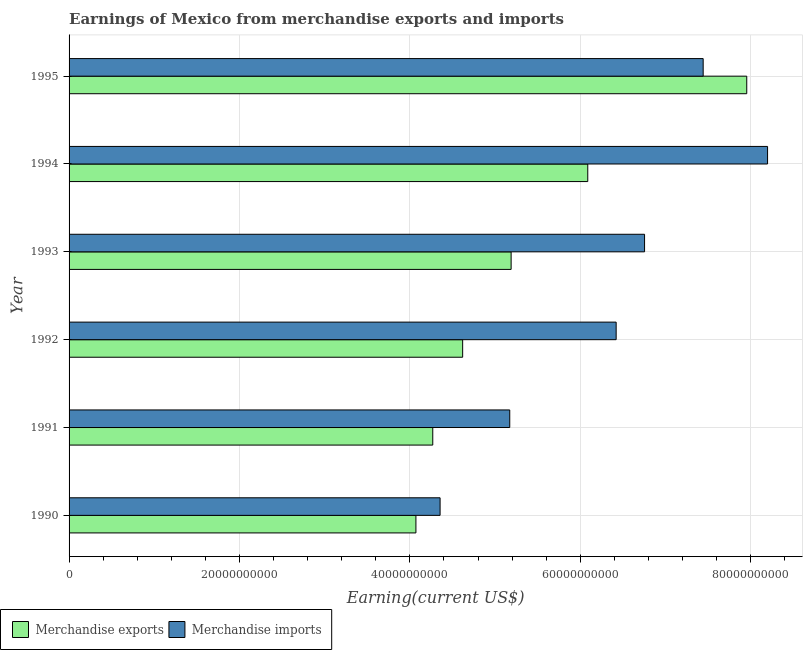How many bars are there on the 5th tick from the bottom?
Offer a very short reply. 2. What is the label of the 2nd group of bars from the top?
Ensure brevity in your answer.  1994. What is the earnings from merchandise exports in 1995?
Your answer should be very brief. 7.95e+1. Across all years, what is the maximum earnings from merchandise exports?
Your response must be concise. 7.95e+1. Across all years, what is the minimum earnings from merchandise imports?
Your answer should be compact. 4.35e+1. What is the total earnings from merchandise imports in the graph?
Keep it short and to the point. 3.83e+11. What is the difference between the earnings from merchandise exports in 1992 and that in 1994?
Make the answer very short. -1.47e+1. What is the difference between the earnings from merchandise imports in 1992 and the earnings from merchandise exports in 1995?
Ensure brevity in your answer.  -1.53e+1. What is the average earnings from merchandise imports per year?
Offer a very short reply. 6.39e+1. In the year 1992, what is the difference between the earnings from merchandise exports and earnings from merchandise imports?
Provide a short and direct response. -1.80e+1. What is the ratio of the earnings from merchandise exports in 1993 to that in 1995?
Give a very brief answer. 0.65. Is the difference between the earnings from merchandise exports in 1990 and 1991 greater than the difference between the earnings from merchandise imports in 1990 and 1991?
Your answer should be compact. Yes. What is the difference between the highest and the second highest earnings from merchandise exports?
Keep it short and to the point. 1.87e+1. What is the difference between the highest and the lowest earnings from merchandise exports?
Make the answer very short. 3.88e+1. Is the sum of the earnings from merchandise imports in 1991 and 1995 greater than the maximum earnings from merchandise exports across all years?
Offer a very short reply. Yes. What does the 2nd bar from the top in 1995 represents?
Offer a terse response. Merchandise exports. What does the 2nd bar from the bottom in 1991 represents?
Give a very brief answer. Merchandise imports. How many years are there in the graph?
Your response must be concise. 6. What is the difference between two consecutive major ticks on the X-axis?
Keep it short and to the point. 2.00e+1. Are the values on the major ticks of X-axis written in scientific E-notation?
Provide a succinct answer. No. How many legend labels are there?
Provide a short and direct response. 2. How are the legend labels stacked?
Provide a succinct answer. Horizontal. What is the title of the graph?
Ensure brevity in your answer.  Earnings of Mexico from merchandise exports and imports. What is the label or title of the X-axis?
Your answer should be compact. Earning(current US$). What is the label or title of the Y-axis?
Your answer should be compact. Year. What is the Earning(current US$) in Merchandise exports in 1990?
Your response must be concise. 4.07e+1. What is the Earning(current US$) in Merchandise imports in 1990?
Offer a terse response. 4.35e+1. What is the Earning(current US$) of Merchandise exports in 1991?
Make the answer very short. 4.27e+1. What is the Earning(current US$) of Merchandise imports in 1991?
Provide a succinct answer. 5.17e+1. What is the Earning(current US$) in Merchandise exports in 1992?
Your answer should be compact. 4.62e+1. What is the Earning(current US$) of Merchandise imports in 1992?
Your answer should be compact. 6.42e+1. What is the Earning(current US$) in Merchandise exports in 1993?
Offer a very short reply. 5.19e+1. What is the Earning(current US$) of Merchandise imports in 1993?
Your answer should be very brief. 6.75e+1. What is the Earning(current US$) of Merchandise exports in 1994?
Give a very brief answer. 6.09e+1. What is the Earning(current US$) in Merchandise imports in 1994?
Keep it short and to the point. 8.20e+1. What is the Earning(current US$) in Merchandise exports in 1995?
Your answer should be compact. 7.95e+1. What is the Earning(current US$) of Merchandise imports in 1995?
Keep it short and to the point. 7.44e+1. Across all years, what is the maximum Earning(current US$) in Merchandise exports?
Make the answer very short. 7.95e+1. Across all years, what is the maximum Earning(current US$) in Merchandise imports?
Your answer should be compact. 8.20e+1. Across all years, what is the minimum Earning(current US$) of Merchandise exports?
Your answer should be compact. 4.07e+1. Across all years, what is the minimum Earning(current US$) in Merchandise imports?
Give a very brief answer. 4.35e+1. What is the total Earning(current US$) in Merchandise exports in the graph?
Your answer should be very brief. 3.22e+11. What is the total Earning(current US$) in Merchandise imports in the graph?
Provide a succinct answer. 3.83e+11. What is the difference between the Earning(current US$) in Merchandise exports in 1990 and that in 1991?
Ensure brevity in your answer.  -1.98e+09. What is the difference between the Earning(current US$) in Merchandise imports in 1990 and that in 1991?
Offer a very short reply. -8.18e+09. What is the difference between the Earning(current US$) of Merchandise exports in 1990 and that in 1992?
Your answer should be compact. -5.48e+09. What is the difference between the Earning(current US$) of Merchandise imports in 1990 and that in 1992?
Offer a terse response. -2.07e+1. What is the difference between the Earning(current US$) in Merchandise exports in 1990 and that in 1993?
Offer a terse response. -1.12e+1. What is the difference between the Earning(current US$) of Merchandise imports in 1990 and that in 1993?
Offer a terse response. -2.40e+1. What is the difference between the Earning(current US$) of Merchandise exports in 1990 and that in 1994?
Give a very brief answer. -2.02e+1. What is the difference between the Earning(current US$) of Merchandise imports in 1990 and that in 1994?
Your response must be concise. -3.84e+1. What is the difference between the Earning(current US$) in Merchandise exports in 1990 and that in 1995?
Offer a very short reply. -3.88e+1. What is the difference between the Earning(current US$) of Merchandise imports in 1990 and that in 1995?
Offer a very short reply. -3.09e+1. What is the difference between the Earning(current US$) in Merchandise exports in 1991 and that in 1992?
Offer a terse response. -3.51e+09. What is the difference between the Earning(current US$) in Merchandise imports in 1991 and that in 1992?
Offer a very short reply. -1.25e+1. What is the difference between the Earning(current US$) in Merchandise exports in 1991 and that in 1993?
Provide a succinct answer. -9.20e+09. What is the difference between the Earning(current US$) in Merchandise imports in 1991 and that in 1993?
Provide a succinct answer. -1.58e+1. What is the difference between the Earning(current US$) in Merchandise exports in 1991 and that in 1994?
Provide a short and direct response. -1.82e+1. What is the difference between the Earning(current US$) of Merchandise imports in 1991 and that in 1994?
Your answer should be very brief. -3.03e+1. What is the difference between the Earning(current US$) in Merchandise exports in 1991 and that in 1995?
Offer a very short reply. -3.69e+1. What is the difference between the Earning(current US$) of Merchandise imports in 1991 and that in 1995?
Make the answer very short. -2.27e+1. What is the difference between the Earning(current US$) in Merchandise exports in 1992 and that in 1993?
Make the answer very short. -5.69e+09. What is the difference between the Earning(current US$) of Merchandise imports in 1992 and that in 1993?
Offer a terse response. -3.33e+09. What is the difference between the Earning(current US$) of Merchandise exports in 1992 and that in 1994?
Your response must be concise. -1.47e+1. What is the difference between the Earning(current US$) in Merchandise imports in 1992 and that in 1994?
Provide a succinct answer. -1.78e+1. What is the difference between the Earning(current US$) of Merchandise exports in 1992 and that in 1995?
Make the answer very short. -3.33e+1. What is the difference between the Earning(current US$) in Merchandise imports in 1992 and that in 1995?
Give a very brief answer. -1.02e+1. What is the difference between the Earning(current US$) of Merchandise exports in 1993 and that in 1994?
Your answer should be compact. -9.00e+09. What is the difference between the Earning(current US$) of Merchandise imports in 1993 and that in 1994?
Offer a terse response. -1.44e+1. What is the difference between the Earning(current US$) in Merchandise exports in 1993 and that in 1995?
Keep it short and to the point. -2.77e+1. What is the difference between the Earning(current US$) in Merchandise imports in 1993 and that in 1995?
Your response must be concise. -6.88e+09. What is the difference between the Earning(current US$) of Merchandise exports in 1994 and that in 1995?
Offer a very short reply. -1.87e+1. What is the difference between the Earning(current US$) in Merchandise imports in 1994 and that in 1995?
Make the answer very short. 7.56e+09. What is the difference between the Earning(current US$) of Merchandise exports in 1990 and the Earning(current US$) of Merchandise imports in 1991?
Offer a very short reply. -1.10e+1. What is the difference between the Earning(current US$) in Merchandise exports in 1990 and the Earning(current US$) in Merchandise imports in 1992?
Offer a terse response. -2.35e+1. What is the difference between the Earning(current US$) in Merchandise exports in 1990 and the Earning(current US$) in Merchandise imports in 1993?
Offer a very short reply. -2.68e+1. What is the difference between the Earning(current US$) in Merchandise exports in 1990 and the Earning(current US$) in Merchandise imports in 1994?
Provide a short and direct response. -4.13e+1. What is the difference between the Earning(current US$) in Merchandise exports in 1990 and the Earning(current US$) in Merchandise imports in 1995?
Provide a succinct answer. -3.37e+1. What is the difference between the Earning(current US$) in Merchandise exports in 1991 and the Earning(current US$) in Merchandise imports in 1992?
Offer a terse response. -2.15e+1. What is the difference between the Earning(current US$) in Merchandise exports in 1991 and the Earning(current US$) in Merchandise imports in 1993?
Your response must be concise. -2.49e+1. What is the difference between the Earning(current US$) of Merchandise exports in 1991 and the Earning(current US$) of Merchandise imports in 1994?
Provide a short and direct response. -3.93e+1. What is the difference between the Earning(current US$) in Merchandise exports in 1991 and the Earning(current US$) in Merchandise imports in 1995?
Provide a short and direct response. -3.17e+1. What is the difference between the Earning(current US$) of Merchandise exports in 1992 and the Earning(current US$) of Merchandise imports in 1993?
Offer a very short reply. -2.14e+1. What is the difference between the Earning(current US$) of Merchandise exports in 1992 and the Earning(current US$) of Merchandise imports in 1994?
Offer a very short reply. -3.58e+1. What is the difference between the Earning(current US$) of Merchandise exports in 1992 and the Earning(current US$) of Merchandise imports in 1995?
Your answer should be compact. -2.82e+1. What is the difference between the Earning(current US$) in Merchandise exports in 1993 and the Earning(current US$) in Merchandise imports in 1994?
Offer a terse response. -3.01e+1. What is the difference between the Earning(current US$) in Merchandise exports in 1993 and the Earning(current US$) in Merchandise imports in 1995?
Your answer should be very brief. -2.25e+1. What is the difference between the Earning(current US$) of Merchandise exports in 1994 and the Earning(current US$) of Merchandise imports in 1995?
Provide a succinct answer. -1.35e+1. What is the average Earning(current US$) of Merchandise exports per year?
Offer a terse response. 5.37e+1. What is the average Earning(current US$) of Merchandise imports per year?
Provide a short and direct response. 6.39e+1. In the year 1990, what is the difference between the Earning(current US$) in Merchandise exports and Earning(current US$) in Merchandise imports?
Offer a very short reply. -2.84e+09. In the year 1991, what is the difference between the Earning(current US$) of Merchandise exports and Earning(current US$) of Merchandise imports?
Keep it short and to the point. -9.04e+09. In the year 1992, what is the difference between the Earning(current US$) in Merchandise exports and Earning(current US$) in Merchandise imports?
Your answer should be very brief. -1.80e+1. In the year 1993, what is the difference between the Earning(current US$) of Merchandise exports and Earning(current US$) of Merchandise imports?
Give a very brief answer. -1.57e+1. In the year 1994, what is the difference between the Earning(current US$) in Merchandise exports and Earning(current US$) in Merchandise imports?
Provide a short and direct response. -2.11e+1. In the year 1995, what is the difference between the Earning(current US$) of Merchandise exports and Earning(current US$) of Merchandise imports?
Ensure brevity in your answer.  5.11e+09. What is the ratio of the Earning(current US$) of Merchandise exports in 1990 to that in 1991?
Provide a succinct answer. 0.95. What is the ratio of the Earning(current US$) of Merchandise imports in 1990 to that in 1991?
Provide a succinct answer. 0.84. What is the ratio of the Earning(current US$) of Merchandise exports in 1990 to that in 1992?
Offer a terse response. 0.88. What is the ratio of the Earning(current US$) of Merchandise imports in 1990 to that in 1992?
Ensure brevity in your answer.  0.68. What is the ratio of the Earning(current US$) in Merchandise exports in 1990 to that in 1993?
Give a very brief answer. 0.78. What is the ratio of the Earning(current US$) in Merchandise imports in 1990 to that in 1993?
Keep it short and to the point. 0.64. What is the ratio of the Earning(current US$) in Merchandise exports in 1990 to that in 1994?
Ensure brevity in your answer.  0.67. What is the ratio of the Earning(current US$) of Merchandise imports in 1990 to that in 1994?
Offer a very short reply. 0.53. What is the ratio of the Earning(current US$) in Merchandise exports in 1990 to that in 1995?
Your answer should be very brief. 0.51. What is the ratio of the Earning(current US$) of Merchandise imports in 1990 to that in 1995?
Give a very brief answer. 0.59. What is the ratio of the Earning(current US$) of Merchandise exports in 1991 to that in 1992?
Provide a succinct answer. 0.92. What is the ratio of the Earning(current US$) of Merchandise imports in 1991 to that in 1992?
Your answer should be very brief. 0.81. What is the ratio of the Earning(current US$) in Merchandise exports in 1991 to that in 1993?
Provide a short and direct response. 0.82. What is the ratio of the Earning(current US$) in Merchandise imports in 1991 to that in 1993?
Keep it short and to the point. 0.77. What is the ratio of the Earning(current US$) in Merchandise exports in 1991 to that in 1994?
Your response must be concise. 0.7. What is the ratio of the Earning(current US$) of Merchandise imports in 1991 to that in 1994?
Your answer should be compact. 0.63. What is the ratio of the Earning(current US$) of Merchandise exports in 1991 to that in 1995?
Your response must be concise. 0.54. What is the ratio of the Earning(current US$) in Merchandise imports in 1991 to that in 1995?
Your answer should be compact. 0.69. What is the ratio of the Earning(current US$) in Merchandise exports in 1992 to that in 1993?
Your answer should be compact. 0.89. What is the ratio of the Earning(current US$) in Merchandise imports in 1992 to that in 1993?
Provide a succinct answer. 0.95. What is the ratio of the Earning(current US$) of Merchandise exports in 1992 to that in 1994?
Provide a succinct answer. 0.76. What is the ratio of the Earning(current US$) in Merchandise imports in 1992 to that in 1994?
Offer a terse response. 0.78. What is the ratio of the Earning(current US$) in Merchandise exports in 1992 to that in 1995?
Your answer should be compact. 0.58. What is the ratio of the Earning(current US$) in Merchandise imports in 1992 to that in 1995?
Offer a very short reply. 0.86. What is the ratio of the Earning(current US$) of Merchandise exports in 1993 to that in 1994?
Keep it short and to the point. 0.85. What is the ratio of the Earning(current US$) in Merchandise imports in 1993 to that in 1994?
Your response must be concise. 0.82. What is the ratio of the Earning(current US$) of Merchandise exports in 1993 to that in 1995?
Your response must be concise. 0.65. What is the ratio of the Earning(current US$) of Merchandise imports in 1993 to that in 1995?
Keep it short and to the point. 0.91. What is the ratio of the Earning(current US$) of Merchandise exports in 1994 to that in 1995?
Provide a succinct answer. 0.77. What is the ratio of the Earning(current US$) of Merchandise imports in 1994 to that in 1995?
Provide a short and direct response. 1.1. What is the difference between the highest and the second highest Earning(current US$) of Merchandise exports?
Your answer should be compact. 1.87e+1. What is the difference between the highest and the second highest Earning(current US$) in Merchandise imports?
Keep it short and to the point. 7.56e+09. What is the difference between the highest and the lowest Earning(current US$) of Merchandise exports?
Provide a short and direct response. 3.88e+1. What is the difference between the highest and the lowest Earning(current US$) in Merchandise imports?
Offer a terse response. 3.84e+1. 